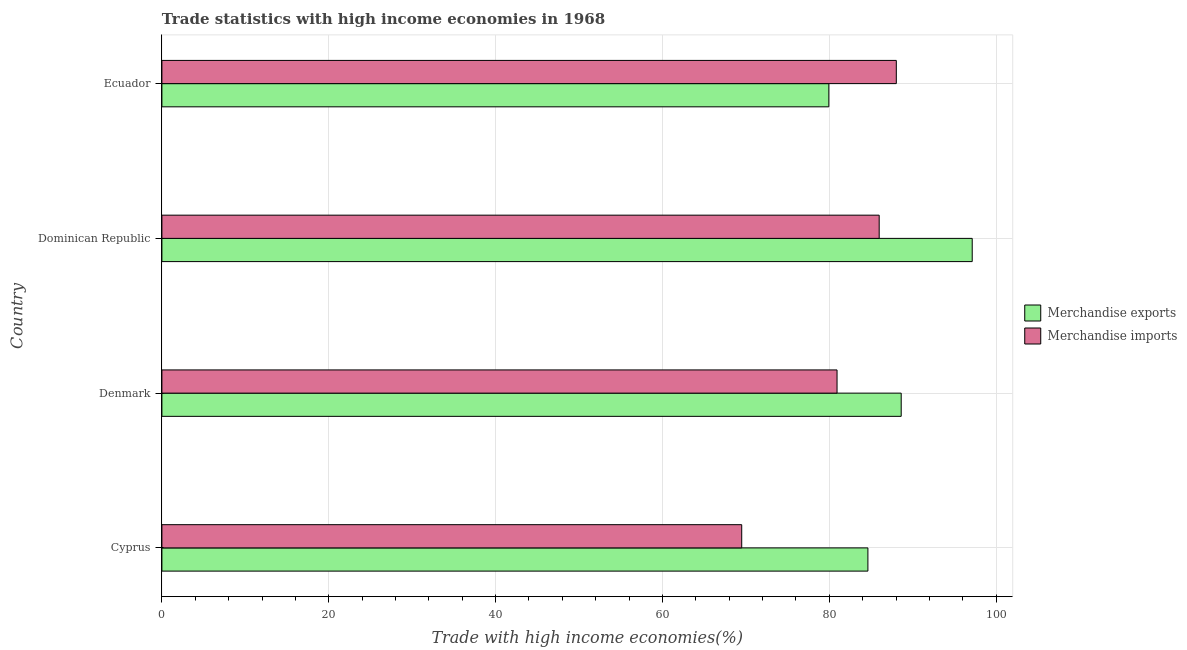How many different coloured bars are there?
Your answer should be compact. 2. Are the number of bars on each tick of the Y-axis equal?
Your response must be concise. Yes. How many bars are there on the 4th tick from the top?
Offer a terse response. 2. What is the merchandise exports in Ecuador?
Offer a terse response. 79.94. Across all countries, what is the maximum merchandise imports?
Your answer should be very brief. 88.03. Across all countries, what is the minimum merchandise exports?
Provide a short and direct response. 79.94. In which country was the merchandise exports maximum?
Your answer should be very brief. Dominican Republic. In which country was the merchandise imports minimum?
Ensure brevity in your answer.  Cyprus. What is the total merchandise imports in the graph?
Offer a terse response. 324.43. What is the difference between the merchandise imports in Cyprus and that in Denmark?
Your response must be concise. -11.43. What is the difference between the merchandise exports in Dominican Republic and the merchandise imports in Denmark?
Ensure brevity in your answer.  16.2. What is the average merchandise imports per country?
Your answer should be compact. 81.11. What is the difference between the merchandise imports and merchandise exports in Ecuador?
Make the answer very short. 8.09. In how many countries, is the merchandise imports greater than 56 %?
Provide a succinct answer. 4. What is the ratio of the merchandise exports in Cyprus to that in Dominican Republic?
Ensure brevity in your answer.  0.87. Is the merchandise exports in Denmark less than that in Dominican Republic?
Give a very brief answer. Yes. What is the difference between the highest and the second highest merchandise imports?
Your answer should be compact. 2.05. What is the difference between the highest and the lowest merchandise imports?
Give a very brief answer. 18.53. What does the 1st bar from the top in Ecuador represents?
Your response must be concise. Merchandise imports. Are all the bars in the graph horizontal?
Keep it short and to the point. Yes. How many countries are there in the graph?
Give a very brief answer. 4. Are the values on the major ticks of X-axis written in scientific E-notation?
Provide a short and direct response. No. Where does the legend appear in the graph?
Your answer should be compact. Center right. What is the title of the graph?
Your answer should be compact. Trade statistics with high income economies in 1968. What is the label or title of the X-axis?
Give a very brief answer. Trade with high income economies(%). What is the label or title of the Y-axis?
Ensure brevity in your answer.  Country. What is the Trade with high income economies(%) in Merchandise exports in Cyprus?
Offer a terse response. 84.62. What is the Trade with high income economies(%) of Merchandise imports in Cyprus?
Keep it short and to the point. 69.5. What is the Trade with high income economies(%) in Merchandise exports in Denmark?
Provide a succinct answer. 88.61. What is the Trade with high income economies(%) in Merchandise imports in Denmark?
Provide a succinct answer. 80.93. What is the Trade with high income economies(%) of Merchandise exports in Dominican Republic?
Make the answer very short. 97.13. What is the Trade with high income economies(%) in Merchandise imports in Dominican Republic?
Provide a short and direct response. 85.98. What is the Trade with high income economies(%) of Merchandise exports in Ecuador?
Provide a succinct answer. 79.94. What is the Trade with high income economies(%) of Merchandise imports in Ecuador?
Offer a very short reply. 88.03. Across all countries, what is the maximum Trade with high income economies(%) of Merchandise exports?
Your answer should be compact. 97.13. Across all countries, what is the maximum Trade with high income economies(%) of Merchandise imports?
Keep it short and to the point. 88.03. Across all countries, what is the minimum Trade with high income economies(%) in Merchandise exports?
Keep it short and to the point. 79.94. Across all countries, what is the minimum Trade with high income economies(%) of Merchandise imports?
Give a very brief answer. 69.5. What is the total Trade with high income economies(%) of Merchandise exports in the graph?
Make the answer very short. 350.31. What is the total Trade with high income economies(%) in Merchandise imports in the graph?
Provide a short and direct response. 324.43. What is the difference between the Trade with high income economies(%) of Merchandise exports in Cyprus and that in Denmark?
Ensure brevity in your answer.  -3.99. What is the difference between the Trade with high income economies(%) in Merchandise imports in Cyprus and that in Denmark?
Give a very brief answer. -11.43. What is the difference between the Trade with high income economies(%) in Merchandise exports in Cyprus and that in Dominican Republic?
Offer a very short reply. -12.5. What is the difference between the Trade with high income economies(%) in Merchandise imports in Cyprus and that in Dominican Republic?
Your answer should be compact. -16.48. What is the difference between the Trade with high income economies(%) of Merchandise exports in Cyprus and that in Ecuador?
Make the answer very short. 4.68. What is the difference between the Trade with high income economies(%) of Merchandise imports in Cyprus and that in Ecuador?
Provide a short and direct response. -18.53. What is the difference between the Trade with high income economies(%) in Merchandise exports in Denmark and that in Dominican Republic?
Your answer should be very brief. -8.51. What is the difference between the Trade with high income economies(%) of Merchandise imports in Denmark and that in Dominican Republic?
Provide a short and direct response. -5.05. What is the difference between the Trade with high income economies(%) in Merchandise exports in Denmark and that in Ecuador?
Make the answer very short. 8.67. What is the difference between the Trade with high income economies(%) of Merchandise imports in Denmark and that in Ecuador?
Provide a succinct answer. -7.1. What is the difference between the Trade with high income economies(%) in Merchandise exports in Dominican Republic and that in Ecuador?
Provide a short and direct response. 17.18. What is the difference between the Trade with high income economies(%) of Merchandise imports in Dominican Republic and that in Ecuador?
Make the answer very short. -2.05. What is the difference between the Trade with high income economies(%) in Merchandise exports in Cyprus and the Trade with high income economies(%) in Merchandise imports in Denmark?
Give a very brief answer. 3.7. What is the difference between the Trade with high income economies(%) of Merchandise exports in Cyprus and the Trade with high income economies(%) of Merchandise imports in Dominican Republic?
Make the answer very short. -1.35. What is the difference between the Trade with high income economies(%) of Merchandise exports in Cyprus and the Trade with high income economies(%) of Merchandise imports in Ecuador?
Your response must be concise. -3.41. What is the difference between the Trade with high income economies(%) of Merchandise exports in Denmark and the Trade with high income economies(%) of Merchandise imports in Dominican Republic?
Keep it short and to the point. 2.64. What is the difference between the Trade with high income economies(%) of Merchandise exports in Denmark and the Trade with high income economies(%) of Merchandise imports in Ecuador?
Give a very brief answer. 0.58. What is the difference between the Trade with high income economies(%) in Merchandise exports in Dominican Republic and the Trade with high income economies(%) in Merchandise imports in Ecuador?
Ensure brevity in your answer.  9.1. What is the average Trade with high income economies(%) of Merchandise exports per country?
Keep it short and to the point. 87.58. What is the average Trade with high income economies(%) in Merchandise imports per country?
Give a very brief answer. 81.11. What is the difference between the Trade with high income economies(%) of Merchandise exports and Trade with high income economies(%) of Merchandise imports in Cyprus?
Your answer should be compact. 15.12. What is the difference between the Trade with high income economies(%) in Merchandise exports and Trade with high income economies(%) in Merchandise imports in Denmark?
Offer a terse response. 7.69. What is the difference between the Trade with high income economies(%) in Merchandise exports and Trade with high income economies(%) in Merchandise imports in Dominican Republic?
Provide a short and direct response. 11.15. What is the difference between the Trade with high income economies(%) of Merchandise exports and Trade with high income economies(%) of Merchandise imports in Ecuador?
Your response must be concise. -8.09. What is the ratio of the Trade with high income economies(%) of Merchandise exports in Cyprus to that in Denmark?
Make the answer very short. 0.95. What is the ratio of the Trade with high income economies(%) of Merchandise imports in Cyprus to that in Denmark?
Your answer should be compact. 0.86. What is the ratio of the Trade with high income economies(%) of Merchandise exports in Cyprus to that in Dominican Republic?
Offer a very short reply. 0.87. What is the ratio of the Trade with high income economies(%) of Merchandise imports in Cyprus to that in Dominican Republic?
Make the answer very short. 0.81. What is the ratio of the Trade with high income economies(%) of Merchandise exports in Cyprus to that in Ecuador?
Ensure brevity in your answer.  1.06. What is the ratio of the Trade with high income economies(%) of Merchandise imports in Cyprus to that in Ecuador?
Make the answer very short. 0.79. What is the ratio of the Trade with high income economies(%) in Merchandise exports in Denmark to that in Dominican Republic?
Make the answer very short. 0.91. What is the ratio of the Trade with high income economies(%) of Merchandise exports in Denmark to that in Ecuador?
Your response must be concise. 1.11. What is the ratio of the Trade with high income economies(%) in Merchandise imports in Denmark to that in Ecuador?
Offer a terse response. 0.92. What is the ratio of the Trade with high income economies(%) in Merchandise exports in Dominican Republic to that in Ecuador?
Give a very brief answer. 1.21. What is the ratio of the Trade with high income economies(%) of Merchandise imports in Dominican Republic to that in Ecuador?
Provide a short and direct response. 0.98. What is the difference between the highest and the second highest Trade with high income economies(%) of Merchandise exports?
Make the answer very short. 8.51. What is the difference between the highest and the second highest Trade with high income economies(%) in Merchandise imports?
Keep it short and to the point. 2.05. What is the difference between the highest and the lowest Trade with high income economies(%) of Merchandise exports?
Give a very brief answer. 17.18. What is the difference between the highest and the lowest Trade with high income economies(%) in Merchandise imports?
Ensure brevity in your answer.  18.53. 